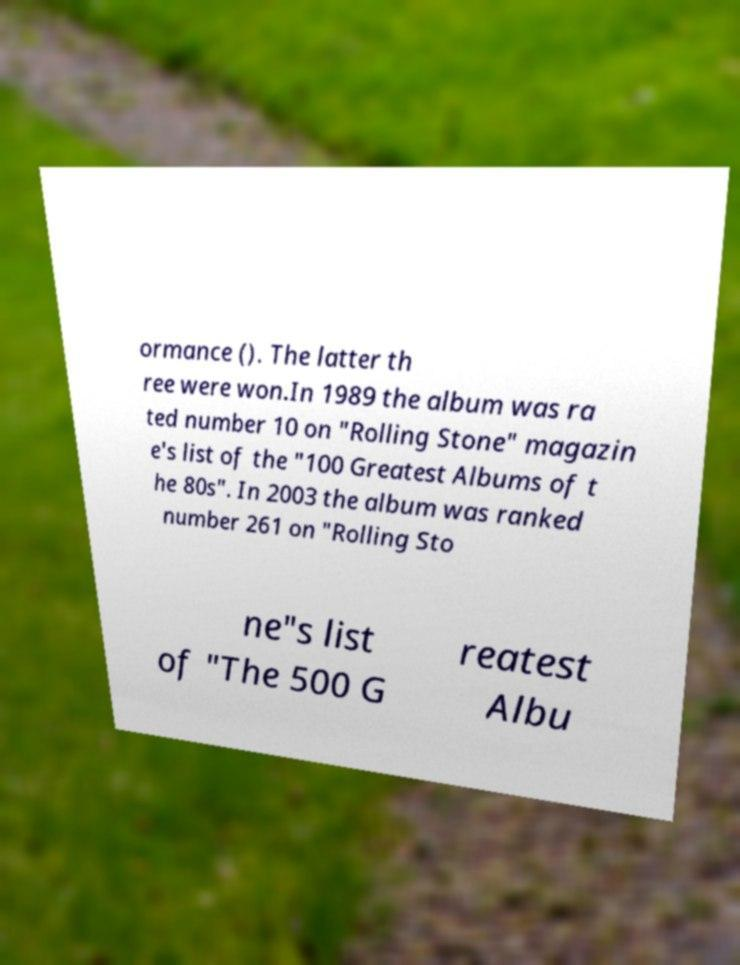For documentation purposes, I need the text within this image transcribed. Could you provide that? ormance (). The latter th ree were won.In 1989 the album was ra ted number 10 on "Rolling Stone" magazin e's list of the "100 Greatest Albums of t he 80s". In 2003 the album was ranked number 261 on "Rolling Sto ne"s list of "The 500 G reatest Albu 